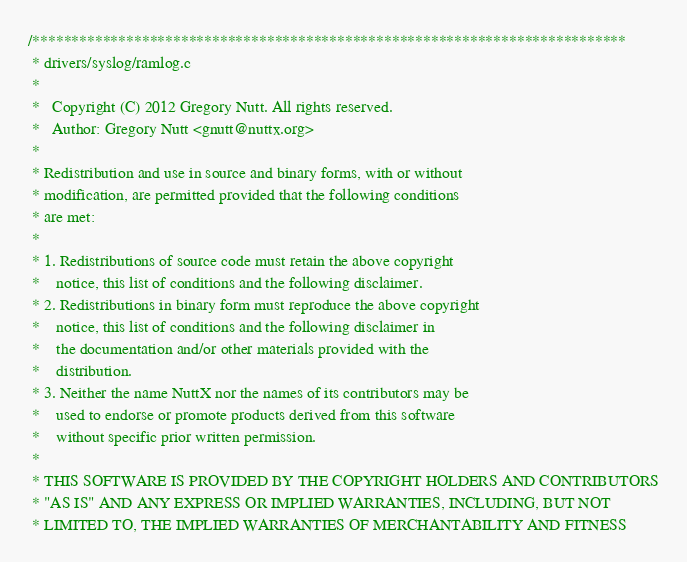<code> <loc_0><loc_0><loc_500><loc_500><_C_>/****************************************************************************
 * drivers/syslog/ramlog.c
 *
 *   Copyright (C) 2012 Gregory Nutt. All rights reserved.
 *   Author: Gregory Nutt <gnutt@nuttx.org>
 *
 * Redistribution and use in source and binary forms, with or without
 * modification, are permitted provided that the following conditions
 * are met:
 *
 * 1. Redistributions of source code must retain the above copyright
 *    notice, this list of conditions and the following disclaimer.
 * 2. Redistributions in binary form must reproduce the above copyright
 *    notice, this list of conditions and the following disclaimer in
 *    the documentation and/or other materials provided with the
 *    distribution.
 * 3. Neither the name NuttX nor the names of its contributors may be
 *    used to endorse or promote products derived from this software
 *    without specific prior written permission.
 *
 * THIS SOFTWARE IS PROVIDED BY THE COPYRIGHT HOLDERS AND CONTRIBUTORS
 * "AS IS" AND ANY EXPRESS OR IMPLIED WARRANTIES, INCLUDING, BUT NOT
 * LIMITED TO, THE IMPLIED WARRANTIES OF MERCHANTABILITY AND FITNESS</code> 